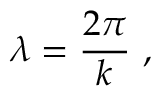<formula> <loc_0><loc_0><loc_500><loc_500>\lambda = { \frac { 2 \pi } { k } } \ ,</formula> 